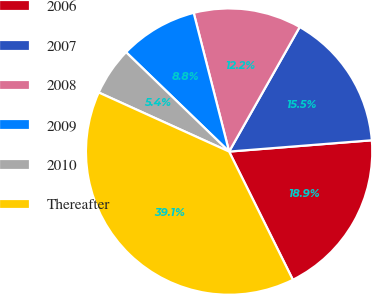<chart> <loc_0><loc_0><loc_500><loc_500><pie_chart><fcel>2006<fcel>2007<fcel>2008<fcel>2009<fcel>2010<fcel>Thereafter<nl><fcel>18.91%<fcel>15.54%<fcel>12.18%<fcel>8.81%<fcel>5.44%<fcel>39.12%<nl></chart> 